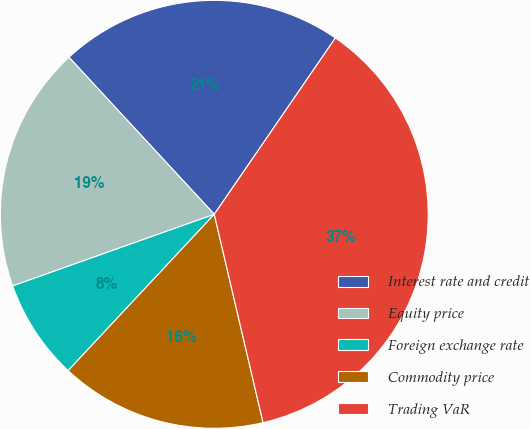Convert chart. <chart><loc_0><loc_0><loc_500><loc_500><pie_chart><fcel>Interest rate and credit<fcel>Equity price<fcel>Foreign exchange rate<fcel>Commodity price<fcel>Trading VaR<nl><fcel>21.46%<fcel>18.55%<fcel>7.6%<fcel>15.63%<fcel>36.76%<nl></chart> 